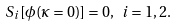Convert formula to latex. <formula><loc_0><loc_0><loc_500><loc_500>S _ { i } [ \phi ( \kappa = 0 ) ] = 0 , \ i = 1 , 2 .</formula> 